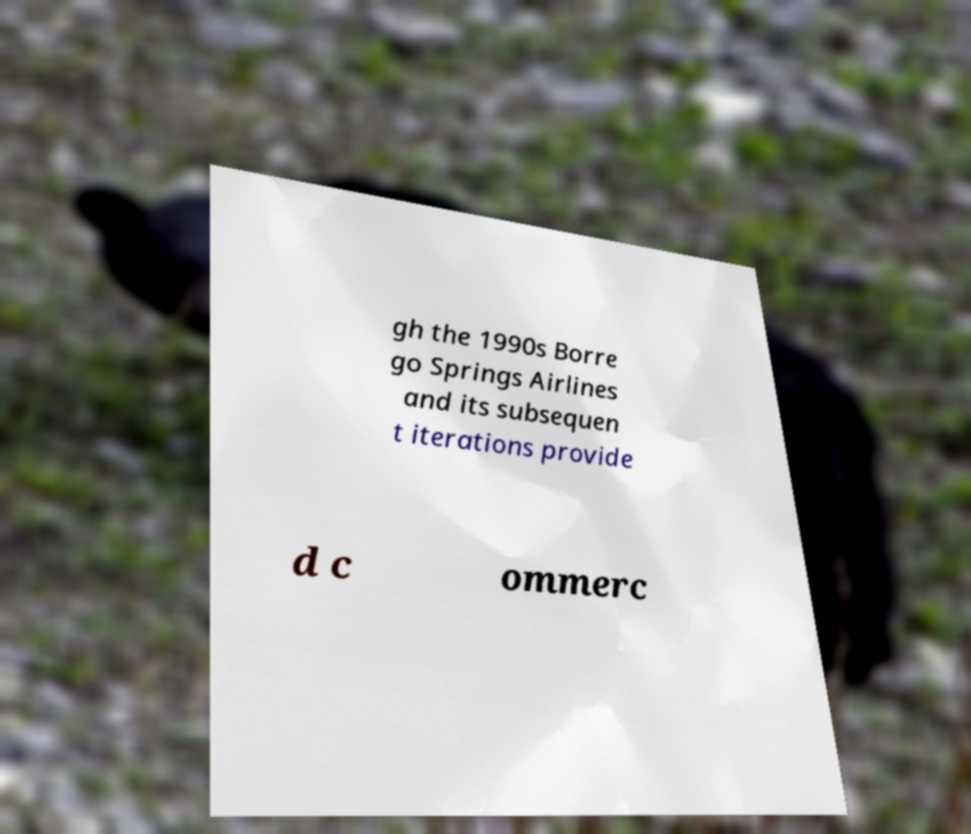Can you read and provide the text displayed in the image?This photo seems to have some interesting text. Can you extract and type it out for me? gh the 1990s Borre go Springs Airlines and its subsequen t iterations provide d c ommerc 